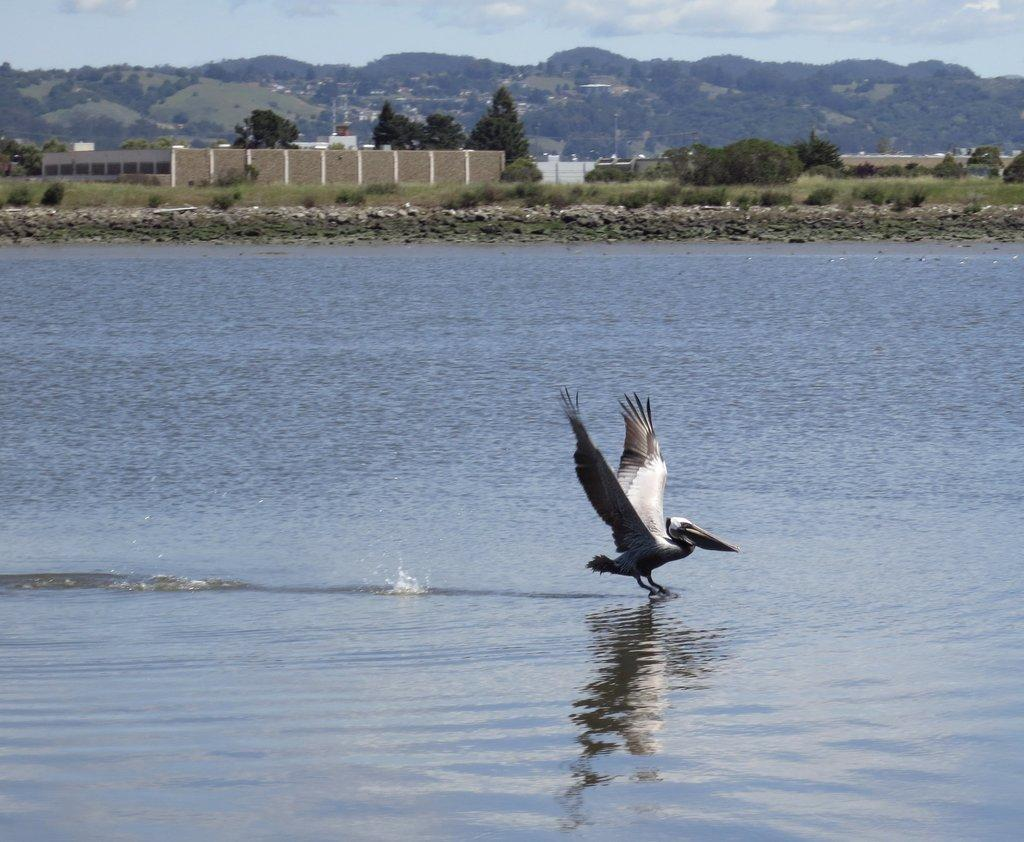What is present in the front of the image? There is water in the front of the image. What can be seen in the center of the image? There is a bird in the center of the image. What type of vegetation is visible in the background of the image? There are trees in the background of the image. What type of structures can be seen in the background of the image? There are buildings in the background of the image. How would you describe the sky in the background of the image? The sky is cloudy in the background of the image. What type of furniture can be seen in the image? There is no furniture present in the image. What type of substance is the bird made of in the image? The bird is a living creature and not a substance; it is made of flesh, bones, and feathers. 